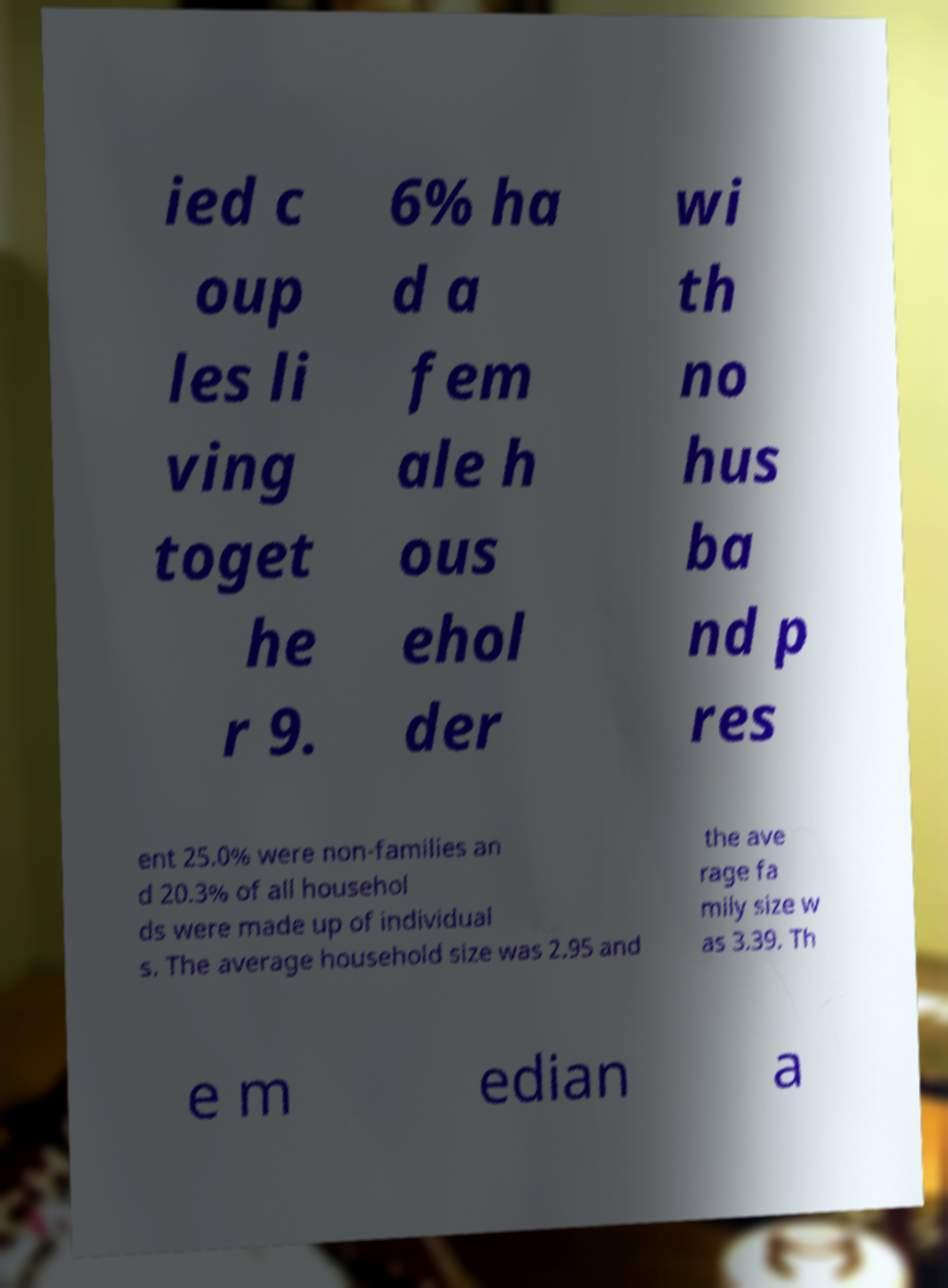I need the written content from this picture converted into text. Can you do that? ied c oup les li ving toget he r 9. 6% ha d a fem ale h ous ehol der wi th no hus ba nd p res ent 25.0% were non-families an d 20.3% of all househol ds were made up of individual s. The average household size was 2.95 and the ave rage fa mily size w as 3.39. Th e m edian a 